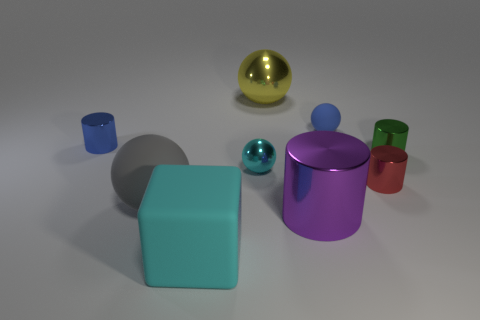Subtract 1 cylinders. How many cylinders are left? 3 Add 1 small shiny spheres. How many objects exist? 10 Subtract all cylinders. How many objects are left? 5 Subtract all cyan things. Subtract all big things. How many objects are left? 3 Add 5 big cyan rubber things. How many big cyan rubber things are left? 6 Add 3 big metal things. How many big metal things exist? 5 Subtract 0 purple blocks. How many objects are left? 9 